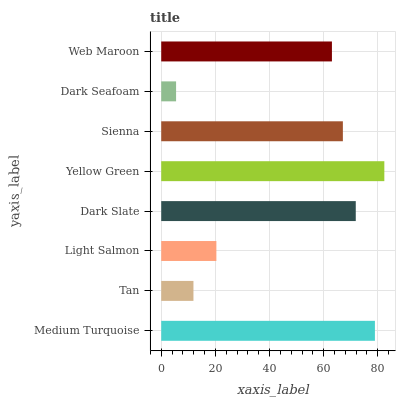Is Dark Seafoam the minimum?
Answer yes or no. Yes. Is Yellow Green the maximum?
Answer yes or no. Yes. Is Tan the minimum?
Answer yes or no. No. Is Tan the maximum?
Answer yes or no. No. Is Medium Turquoise greater than Tan?
Answer yes or no. Yes. Is Tan less than Medium Turquoise?
Answer yes or no. Yes. Is Tan greater than Medium Turquoise?
Answer yes or no. No. Is Medium Turquoise less than Tan?
Answer yes or no. No. Is Sienna the high median?
Answer yes or no. Yes. Is Web Maroon the low median?
Answer yes or no. Yes. Is Dark Slate the high median?
Answer yes or no. No. Is Light Salmon the low median?
Answer yes or no. No. 